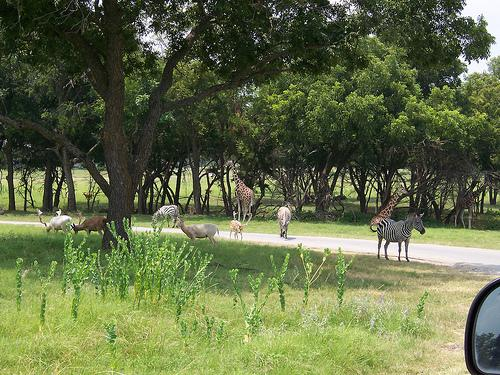Describe the image from the perspective of a nature photographer. Capturing a serene moment in nature, the image showcases animals such as zebras and giraffes gracefully interacting with their surroundings, offering a glimpse of their natural habitat. Mention the interaction between the car and animals in the image. The car's side mirror reveals its proximity to the group of animals as they cross the path or approach the vehicle, possibly following the same direction. Write a short poem inspired by the scene in the image. While a man-made wonder passes by. Explain the role of trees in the image. The trees in the image provide shade and a backdrop for the animals, as well as contribute to the natural scenery of the landscape. Describe the behavior of the animals in the image. The animals, primarily zebras and giraffes, are walking or grazing in the grass, with some of them exploring the paved path and wandering nearby the car. What kind of location does the image seem to take place in? The image appears to take place in a natural setting, possibly a grassland or savannah, where different animal species coexist with sporadic human intervention. Narrate what's happening in the image as if you are a storyteller. Once upon a time, amidst tall grass and towering trees, zebras, giraffes, and other animals wandered peacefully down a path, unaware of the nearby car that had just passed by. Mention the most noticeable element in the image and its implication. The car's side mirror stands out, as it's the only human-made element in the scene, hinting at the interaction between humans and wildlife in this natural environment. Provide a brief overview of the scene depicted in the image. Various animals, including zebras and giraffes, are walking along a path surrounded by grass and trees, while a car with a visible side mirror is nearby. Describe the location where the animals are in the picture. The animals are on a path surrounded by grass and trees, with some of them under the shade of trees and others walking down the path. 